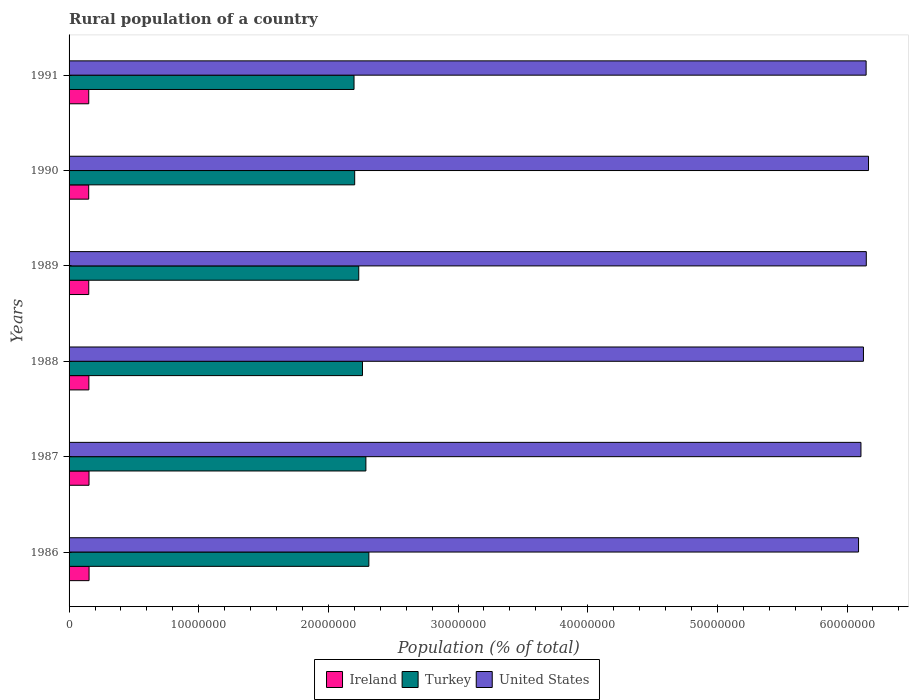How many different coloured bars are there?
Your response must be concise. 3. Are the number of bars per tick equal to the number of legend labels?
Keep it short and to the point. Yes. How many bars are there on the 5th tick from the top?
Give a very brief answer. 3. In how many cases, is the number of bars for a given year not equal to the number of legend labels?
Give a very brief answer. 0. What is the rural population in United States in 1989?
Ensure brevity in your answer.  6.15e+07. Across all years, what is the maximum rural population in Ireland?
Your answer should be very brief. 1.54e+06. Across all years, what is the minimum rural population in United States?
Give a very brief answer. 6.09e+07. What is the total rural population in Ireland in the graph?
Your answer should be very brief. 9.16e+06. What is the difference between the rural population in Ireland in 1987 and that in 1991?
Your answer should be very brief. 2.02e+04. What is the difference between the rural population in Turkey in 1991 and the rural population in Ireland in 1989?
Ensure brevity in your answer.  2.05e+07. What is the average rural population in United States per year?
Provide a short and direct response. 6.13e+07. In the year 1989, what is the difference between the rural population in Turkey and rural population in United States?
Ensure brevity in your answer.  -3.91e+07. In how many years, is the rural population in Ireland greater than 18000000 %?
Make the answer very short. 0. What is the ratio of the rural population in Turkey in 1989 to that in 1991?
Your answer should be compact. 1.02. Is the rural population in Ireland in 1986 less than that in 1988?
Provide a succinct answer. No. Is the difference between the rural population in Turkey in 1986 and 1991 greater than the difference between the rural population in United States in 1986 and 1991?
Your response must be concise. Yes. What is the difference between the highest and the second highest rural population in United States?
Provide a succinct answer. 1.72e+05. What is the difference between the highest and the lowest rural population in Ireland?
Offer a terse response. 2.81e+04. Is the sum of the rural population in United States in 1987 and 1988 greater than the maximum rural population in Ireland across all years?
Offer a terse response. Yes. What does the 2nd bar from the bottom in 1990 represents?
Provide a short and direct response. Turkey. How many bars are there?
Give a very brief answer. 18. How many years are there in the graph?
Offer a very short reply. 6. What is the difference between two consecutive major ticks on the X-axis?
Keep it short and to the point. 1.00e+07. Are the values on the major ticks of X-axis written in scientific E-notation?
Provide a short and direct response. No. Does the graph contain any zero values?
Give a very brief answer. No. Does the graph contain grids?
Offer a terse response. No. How many legend labels are there?
Offer a terse response. 3. What is the title of the graph?
Ensure brevity in your answer.  Rural population of a country. Does "Gambia, The" appear as one of the legend labels in the graph?
Ensure brevity in your answer.  No. What is the label or title of the X-axis?
Your answer should be compact. Population (% of total). What is the Population (% of total) of Ireland in 1986?
Make the answer very short. 1.54e+06. What is the Population (% of total) in Turkey in 1986?
Offer a terse response. 2.31e+07. What is the Population (% of total) in United States in 1986?
Offer a very short reply. 6.09e+07. What is the Population (% of total) of Ireland in 1987?
Keep it short and to the point. 1.54e+06. What is the Population (% of total) in Turkey in 1987?
Offer a very short reply. 2.29e+07. What is the Population (% of total) in United States in 1987?
Ensure brevity in your answer.  6.11e+07. What is the Population (% of total) in Ireland in 1988?
Make the answer very short. 1.53e+06. What is the Population (% of total) in Turkey in 1988?
Your answer should be compact. 2.26e+07. What is the Population (% of total) of United States in 1988?
Provide a succinct answer. 6.13e+07. What is the Population (% of total) in Ireland in 1989?
Keep it short and to the point. 1.52e+06. What is the Population (% of total) of Turkey in 1989?
Give a very brief answer. 2.23e+07. What is the Population (% of total) of United States in 1989?
Provide a succinct answer. 6.15e+07. What is the Population (% of total) of Ireland in 1990?
Provide a succinct answer. 1.51e+06. What is the Population (% of total) in Turkey in 1990?
Offer a terse response. 2.20e+07. What is the Population (% of total) in United States in 1990?
Your answer should be compact. 6.17e+07. What is the Population (% of total) of Ireland in 1991?
Your response must be concise. 1.52e+06. What is the Population (% of total) in Turkey in 1991?
Your answer should be very brief. 2.20e+07. What is the Population (% of total) in United States in 1991?
Ensure brevity in your answer.  6.15e+07. Across all years, what is the maximum Population (% of total) of Ireland?
Provide a short and direct response. 1.54e+06. Across all years, what is the maximum Population (% of total) in Turkey?
Your response must be concise. 2.31e+07. Across all years, what is the maximum Population (% of total) in United States?
Your answer should be compact. 6.17e+07. Across all years, what is the minimum Population (% of total) of Ireland?
Give a very brief answer. 1.51e+06. Across all years, what is the minimum Population (% of total) of Turkey?
Your response must be concise. 2.20e+07. Across all years, what is the minimum Population (% of total) in United States?
Your answer should be compact. 6.09e+07. What is the total Population (% of total) in Ireland in the graph?
Ensure brevity in your answer.  9.16e+06. What is the total Population (% of total) of Turkey in the graph?
Offer a terse response. 1.35e+08. What is the total Population (% of total) in United States in the graph?
Keep it short and to the point. 3.68e+08. What is the difference between the Population (% of total) in Ireland in 1986 and that in 1987?
Give a very brief answer. 4089. What is the difference between the Population (% of total) in Turkey in 1986 and that in 1987?
Your answer should be compact. 2.29e+05. What is the difference between the Population (% of total) in United States in 1986 and that in 1987?
Provide a short and direct response. -1.86e+05. What is the difference between the Population (% of total) in Ireland in 1986 and that in 1988?
Your response must be concise. 1.49e+04. What is the difference between the Population (% of total) in Turkey in 1986 and that in 1988?
Offer a very short reply. 4.92e+05. What is the difference between the Population (% of total) of United States in 1986 and that in 1988?
Ensure brevity in your answer.  -3.78e+05. What is the difference between the Population (% of total) of Ireland in 1986 and that in 1989?
Keep it short and to the point. 2.51e+04. What is the difference between the Population (% of total) of Turkey in 1986 and that in 1989?
Offer a very short reply. 7.80e+05. What is the difference between the Population (% of total) in United States in 1986 and that in 1989?
Your response must be concise. -5.97e+05. What is the difference between the Population (% of total) in Ireland in 1986 and that in 1990?
Your response must be concise. 2.81e+04. What is the difference between the Population (% of total) in Turkey in 1986 and that in 1990?
Offer a very short reply. 1.09e+06. What is the difference between the Population (% of total) of United States in 1986 and that in 1990?
Give a very brief answer. -7.69e+05. What is the difference between the Population (% of total) in Ireland in 1986 and that in 1991?
Offer a very short reply. 2.43e+04. What is the difference between the Population (% of total) of Turkey in 1986 and that in 1991?
Your response must be concise. 1.14e+06. What is the difference between the Population (% of total) in United States in 1986 and that in 1991?
Your response must be concise. -5.84e+05. What is the difference between the Population (% of total) of Ireland in 1987 and that in 1988?
Give a very brief answer. 1.08e+04. What is the difference between the Population (% of total) in Turkey in 1987 and that in 1988?
Ensure brevity in your answer.  2.63e+05. What is the difference between the Population (% of total) in United States in 1987 and that in 1988?
Make the answer very short. -1.93e+05. What is the difference between the Population (% of total) in Ireland in 1987 and that in 1989?
Provide a short and direct response. 2.10e+04. What is the difference between the Population (% of total) in Turkey in 1987 and that in 1989?
Ensure brevity in your answer.  5.51e+05. What is the difference between the Population (% of total) of United States in 1987 and that in 1989?
Offer a very short reply. -4.11e+05. What is the difference between the Population (% of total) of Ireland in 1987 and that in 1990?
Ensure brevity in your answer.  2.40e+04. What is the difference between the Population (% of total) of Turkey in 1987 and that in 1990?
Offer a very short reply. 8.64e+05. What is the difference between the Population (% of total) of United States in 1987 and that in 1990?
Your answer should be compact. -5.83e+05. What is the difference between the Population (% of total) in Ireland in 1987 and that in 1991?
Your answer should be very brief. 2.02e+04. What is the difference between the Population (% of total) in Turkey in 1987 and that in 1991?
Give a very brief answer. 9.15e+05. What is the difference between the Population (% of total) of United States in 1987 and that in 1991?
Your response must be concise. -3.98e+05. What is the difference between the Population (% of total) in Ireland in 1988 and that in 1989?
Give a very brief answer. 1.03e+04. What is the difference between the Population (% of total) of Turkey in 1988 and that in 1989?
Offer a very short reply. 2.88e+05. What is the difference between the Population (% of total) in United States in 1988 and that in 1989?
Make the answer very short. -2.19e+05. What is the difference between the Population (% of total) of Ireland in 1988 and that in 1990?
Your response must be concise. 1.32e+04. What is the difference between the Population (% of total) in Turkey in 1988 and that in 1990?
Your answer should be very brief. 6.01e+05. What is the difference between the Population (% of total) of United States in 1988 and that in 1990?
Offer a very short reply. -3.90e+05. What is the difference between the Population (% of total) of Ireland in 1988 and that in 1991?
Your response must be concise. 9406. What is the difference between the Population (% of total) of Turkey in 1988 and that in 1991?
Your answer should be compact. 6.53e+05. What is the difference between the Population (% of total) of United States in 1988 and that in 1991?
Make the answer very short. -2.05e+05. What is the difference between the Population (% of total) in Ireland in 1989 and that in 1990?
Give a very brief answer. 2935. What is the difference between the Population (% of total) of Turkey in 1989 and that in 1990?
Make the answer very short. 3.13e+05. What is the difference between the Population (% of total) in United States in 1989 and that in 1990?
Your answer should be compact. -1.72e+05. What is the difference between the Population (% of total) in Ireland in 1989 and that in 1991?
Keep it short and to the point. -848. What is the difference between the Population (% of total) of Turkey in 1989 and that in 1991?
Provide a short and direct response. 3.65e+05. What is the difference between the Population (% of total) in United States in 1989 and that in 1991?
Offer a terse response. 1.32e+04. What is the difference between the Population (% of total) in Ireland in 1990 and that in 1991?
Give a very brief answer. -3783. What is the difference between the Population (% of total) of Turkey in 1990 and that in 1991?
Your answer should be compact. 5.12e+04. What is the difference between the Population (% of total) of United States in 1990 and that in 1991?
Offer a very short reply. 1.85e+05. What is the difference between the Population (% of total) of Ireland in 1986 and the Population (% of total) of Turkey in 1987?
Keep it short and to the point. -2.14e+07. What is the difference between the Population (% of total) of Ireland in 1986 and the Population (% of total) of United States in 1987?
Ensure brevity in your answer.  -5.95e+07. What is the difference between the Population (% of total) in Turkey in 1986 and the Population (% of total) in United States in 1987?
Offer a very short reply. -3.80e+07. What is the difference between the Population (% of total) of Ireland in 1986 and the Population (% of total) of Turkey in 1988?
Give a very brief answer. -2.11e+07. What is the difference between the Population (% of total) of Ireland in 1986 and the Population (% of total) of United States in 1988?
Offer a terse response. -5.97e+07. What is the difference between the Population (% of total) of Turkey in 1986 and the Population (% of total) of United States in 1988?
Offer a very short reply. -3.81e+07. What is the difference between the Population (% of total) in Ireland in 1986 and the Population (% of total) in Turkey in 1989?
Your response must be concise. -2.08e+07. What is the difference between the Population (% of total) of Ireland in 1986 and the Population (% of total) of United States in 1989?
Make the answer very short. -5.99e+07. What is the difference between the Population (% of total) in Turkey in 1986 and the Population (% of total) in United States in 1989?
Provide a short and direct response. -3.84e+07. What is the difference between the Population (% of total) of Ireland in 1986 and the Population (% of total) of Turkey in 1990?
Offer a very short reply. -2.05e+07. What is the difference between the Population (% of total) of Ireland in 1986 and the Population (% of total) of United States in 1990?
Ensure brevity in your answer.  -6.01e+07. What is the difference between the Population (% of total) of Turkey in 1986 and the Population (% of total) of United States in 1990?
Keep it short and to the point. -3.85e+07. What is the difference between the Population (% of total) in Ireland in 1986 and the Population (% of total) in Turkey in 1991?
Your response must be concise. -2.04e+07. What is the difference between the Population (% of total) in Ireland in 1986 and the Population (% of total) in United States in 1991?
Your answer should be compact. -5.99e+07. What is the difference between the Population (% of total) in Turkey in 1986 and the Population (% of total) in United States in 1991?
Your response must be concise. -3.84e+07. What is the difference between the Population (% of total) in Ireland in 1987 and the Population (% of total) in Turkey in 1988?
Offer a terse response. -2.11e+07. What is the difference between the Population (% of total) of Ireland in 1987 and the Population (% of total) of United States in 1988?
Ensure brevity in your answer.  -5.97e+07. What is the difference between the Population (% of total) in Turkey in 1987 and the Population (% of total) in United States in 1988?
Provide a short and direct response. -3.84e+07. What is the difference between the Population (% of total) in Ireland in 1987 and the Population (% of total) in Turkey in 1989?
Your answer should be very brief. -2.08e+07. What is the difference between the Population (% of total) of Ireland in 1987 and the Population (% of total) of United States in 1989?
Your answer should be very brief. -5.99e+07. What is the difference between the Population (% of total) of Turkey in 1987 and the Population (% of total) of United States in 1989?
Make the answer very short. -3.86e+07. What is the difference between the Population (% of total) in Ireland in 1987 and the Population (% of total) in Turkey in 1990?
Your answer should be very brief. -2.05e+07. What is the difference between the Population (% of total) of Ireland in 1987 and the Population (% of total) of United States in 1990?
Provide a succinct answer. -6.01e+07. What is the difference between the Population (% of total) of Turkey in 1987 and the Population (% of total) of United States in 1990?
Your response must be concise. -3.88e+07. What is the difference between the Population (% of total) of Ireland in 1987 and the Population (% of total) of Turkey in 1991?
Make the answer very short. -2.04e+07. What is the difference between the Population (% of total) in Ireland in 1987 and the Population (% of total) in United States in 1991?
Provide a succinct answer. -5.99e+07. What is the difference between the Population (% of total) of Turkey in 1987 and the Population (% of total) of United States in 1991?
Your response must be concise. -3.86e+07. What is the difference between the Population (% of total) in Ireland in 1988 and the Population (% of total) in Turkey in 1989?
Provide a short and direct response. -2.08e+07. What is the difference between the Population (% of total) in Ireland in 1988 and the Population (% of total) in United States in 1989?
Ensure brevity in your answer.  -6.00e+07. What is the difference between the Population (% of total) in Turkey in 1988 and the Population (% of total) in United States in 1989?
Your response must be concise. -3.89e+07. What is the difference between the Population (% of total) of Ireland in 1988 and the Population (% of total) of Turkey in 1990?
Your answer should be compact. -2.05e+07. What is the difference between the Population (% of total) in Ireland in 1988 and the Population (% of total) in United States in 1990?
Make the answer very short. -6.01e+07. What is the difference between the Population (% of total) in Turkey in 1988 and the Population (% of total) in United States in 1990?
Offer a very short reply. -3.90e+07. What is the difference between the Population (% of total) in Ireland in 1988 and the Population (% of total) in Turkey in 1991?
Keep it short and to the point. -2.04e+07. What is the difference between the Population (% of total) of Ireland in 1988 and the Population (% of total) of United States in 1991?
Your answer should be compact. -5.99e+07. What is the difference between the Population (% of total) in Turkey in 1988 and the Population (% of total) in United States in 1991?
Your answer should be compact. -3.88e+07. What is the difference between the Population (% of total) in Ireland in 1989 and the Population (% of total) in Turkey in 1990?
Your response must be concise. -2.05e+07. What is the difference between the Population (% of total) of Ireland in 1989 and the Population (% of total) of United States in 1990?
Provide a short and direct response. -6.01e+07. What is the difference between the Population (% of total) in Turkey in 1989 and the Population (% of total) in United States in 1990?
Give a very brief answer. -3.93e+07. What is the difference between the Population (% of total) of Ireland in 1989 and the Population (% of total) of Turkey in 1991?
Your answer should be very brief. -2.05e+07. What is the difference between the Population (% of total) in Ireland in 1989 and the Population (% of total) in United States in 1991?
Give a very brief answer. -6.00e+07. What is the difference between the Population (% of total) in Turkey in 1989 and the Population (% of total) in United States in 1991?
Your answer should be compact. -3.91e+07. What is the difference between the Population (% of total) in Ireland in 1990 and the Population (% of total) in Turkey in 1991?
Keep it short and to the point. -2.05e+07. What is the difference between the Population (% of total) of Ireland in 1990 and the Population (% of total) of United States in 1991?
Provide a succinct answer. -6.00e+07. What is the difference between the Population (% of total) in Turkey in 1990 and the Population (% of total) in United States in 1991?
Your response must be concise. -3.94e+07. What is the average Population (% of total) in Ireland per year?
Ensure brevity in your answer.  1.53e+06. What is the average Population (% of total) of Turkey per year?
Keep it short and to the point. 2.25e+07. What is the average Population (% of total) of United States per year?
Your answer should be very brief. 6.13e+07. In the year 1986, what is the difference between the Population (% of total) of Ireland and Population (% of total) of Turkey?
Make the answer very short. -2.16e+07. In the year 1986, what is the difference between the Population (% of total) of Ireland and Population (% of total) of United States?
Make the answer very short. -5.93e+07. In the year 1986, what is the difference between the Population (% of total) of Turkey and Population (% of total) of United States?
Keep it short and to the point. -3.78e+07. In the year 1987, what is the difference between the Population (% of total) of Ireland and Population (% of total) of Turkey?
Offer a very short reply. -2.14e+07. In the year 1987, what is the difference between the Population (% of total) of Ireland and Population (% of total) of United States?
Offer a terse response. -5.95e+07. In the year 1987, what is the difference between the Population (% of total) in Turkey and Population (% of total) in United States?
Give a very brief answer. -3.82e+07. In the year 1988, what is the difference between the Population (% of total) of Ireland and Population (% of total) of Turkey?
Your answer should be very brief. -2.11e+07. In the year 1988, what is the difference between the Population (% of total) of Ireland and Population (% of total) of United States?
Your answer should be compact. -5.97e+07. In the year 1988, what is the difference between the Population (% of total) in Turkey and Population (% of total) in United States?
Make the answer very short. -3.86e+07. In the year 1989, what is the difference between the Population (% of total) in Ireland and Population (% of total) in Turkey?
Make the answer very short. -2.08e+07. In the year 1989, what is the difference between the Population (% of total) in Ireland and Population (% of total) in United States?
Make the answer very short. -6.00e+07. In the year 1989, what is the difference between the Population (% of total) of Turkey and Population (% of total) of United States?
Provide a short and direct response. -3.91e+07. In the year 1990, what is the difference between the Population (% of total) of Ireland and Population (% of total) of Turkey?
Provide a short and direct response. -2.05e+07. In the year 1990, what is the difference between the Population (% of total) in Ireland and Population (% of total) in United States?
Your response must be concise. -6.01e+07. In the year 1990, what is the difference between the Population (% of total) of Turkey and Population (% of total) of United States?
Provide a succinct answer. -3.96e+07. In the year 1991, what is the difference between the Population (% of total) in Ireland and Population (% of total) in Turkey?
Offer a terse response. -2.05e+07. In the year 1991, what is the difference between the Population (% of total) of Ireland and Population (% of total) of United States?
Your answer should be very brief. -6.00e+07. In the year 1991, what is the difference between the Population (% of total) of Turkey and Population (% of total) of United States?
Ensure brevity in your answer.  -3.95e+07. What is the ratio of the Population (% of total) in Turkey in 1986 to that in 1987?
Provide a succinct answer. 1.01. What is the ratio of the Population (% of total) in United States in 1986 to that in 1987?
Make the answer very short. 1. What is the ratio of the Population (% of total) in Ireland in 1986 to that in 1988?
Your response must be concise. 1.01. What is the ratio of the Population (% of total) of Turkey in 1986 to that in 1988?
Provide a short and direct response. 1.02. What is the ratio of the Population (% of total) of Ireland in 1986 to that in 1989?
Ensure brevity in your answer.  1.02. What is the ratio of the Population (% of total) of Turkey in 1986 to that in 1989?
Offer a terse response. 1.03. What is the ratio of the Population (% of total) in United States in 1986 to that in 1989?
Your answer should be compact. 0.99. What is the ratio of the Population (% of total) in Ireland in 1986 to that in 1990?
Make the answer very short. 1.02. What is the ratio of the Population (% of total) in Turkey in 1986 to that in 1990?
Offer a terse response. 1.05. What is the ratio of the Population (% of total) of United States in 1986 to that in 1990?
Keep it short and to the point. 0.99. What is the ratio of the Population (% of total) of Turkey in 1986 to that in 1991?
Offer a terse response. 1.05. What is the ratio of the Population (% of total) of United States in 1986 to that in 1991?
Keep it short and to the point. 0.99. What is the ratio of the Population (% of total) in Ireland in 1987 to that in 1988?
Your answer should be very brief. 1.01. What is the ratio of the Population (% of total) in Turkey in 1987 to that in 1988?
Your answer should be very brief. 1.01. What is the ratio of the Population (% of total) in Ireland in 1987 to that in 1989?
Offer a very short reply. 1.01. What is the ratio of the Population (% of total) of Turkey in 1987 to that in 1989?
Make the answer very short. 1.02. What is the ratio of the Population (% of total) in Ireland in 1987 to that in 1990?
Offer a very short reply. 1.02. What is the ratio of the Population (% of total) in Turkey in 1987 to that in 1990?
Ensure brevity in your answer.  1.04. What is the ratio of the Population (% of total) of United States in 1987 to that in 1990?
Keep it short and to the point. 0.99. What is the ratio of the Population (% of total) of Ireland in 1987 to that in 1991?
Make the answer very short. 1.01. What is the ratio of the Population (% of total) of Turkey in 1987 to that in 1991?
Keep it short and to the point. 1.04. What is the ratio of the Population (% of total) of United States in 1987 to that in 1991?
Your response must be concise. 0.99. What is the ratio of the Population (% of total) of Ireland in 1988 to that in 1989?
Provide a succinct answer. 1.01. What is the ratio of the Population (% of total) in Turkey in 1988 to that in 1989?
Provide a short and direct response. 1.01. What is the ratio of the Population (% of total) of United States in 1988 to that in 1989?
Offer a terse response. 1. What is the ratio of the Population (% of total) of Ireland in 1988 to that in 1990?
Offer a terse response. 1.01. What is the ratio of the Population (% of total) in Turkey in 1988 to that in 1990?
Your answer should be very brief. 1.03. What is the ratio of the Population (% of total) of United States in 1988 to that in 1990?
Give a very brief answer. 0.99. What is the ratio of the Population (% of total) in Ireland in 1988 to that in 1991?
Keep it short and to the point. 1.01. What is the ratio of the Population (% of total) in Turkey in 1988 to that in 1991?
Give a very brief answer. 1.03. What is the ratio of the Population (% of total) in United States in 1988 to that in 1991?
Give a very brief answer. 1. What is the ratio of the Population (% of total) of Turkey in 1989 to that in 1990?
Your answer should be compact. 1.01. What is the ratio of the Population (% of total) of Turkey in 1989 to that in 1991?
Keep it short and to the point. 1.02. What is the ratio of the Population (% of total) in Ireland in 1990 to that in 1991?
Offer a terse response. 1. What is the ratio of the Population (% of total) of Turkey in 1990 to that in 1991?
Keep it short and to the point. 1. What is the difference between the highest and the second highest Population (% of total) in Ireland?
Provide a short and direct response. 4089. What is the difference between the highest and the second highest Population (% of total) of Turkey?
Your answer should be very brief. 2.29e+05. What is the difference between the highest and the second highest Population (% of total) of United States?
Make the answer very short. 1.72e+05. What is the difference between the highest and the lowest Population (% of total) of Ireland?
Provide a short and direct response. 2.81e+04. What is the difference between the highest and the lowest Population (% of total) of Turkey?
Provide a succinct answer. 1.14e+06. What is the difference between the highest and the lowest Population (% of total) of United States?
Make the answer very short. 7.69e+05. 